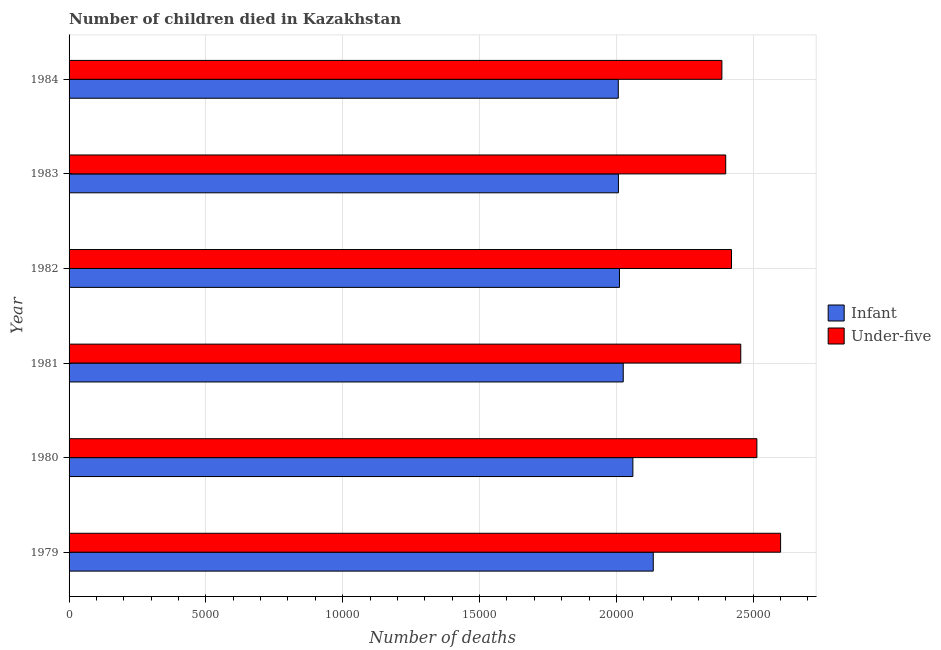How many different coloured bars are there?
Keep it short and to the point. 2. What is the label of the 3rd group of bars from the top?
Keep it short and to the point. 1982. What is the number of infant deaths in 1979?
Keep it short and to the point. 2.13e+04. Across all years, what is the maximum number of under-five deaths?
Offer a terse response. 2.60e+04. Across all years, what is the minimum number of infant deaths?
Keep it short and to the point. 2.01e+04. In which year was the number of infant deaths maximum?
Ensure brevity in your answer.  1979. In which year was the number of under-five deaths minimum?
Give a very brief answer. 1984. What is the total number of infant deaths in the graph?
Offer a terse response. 1.22e+05. What is the difference between the number of infant deaths in 1981 and that in 1984?
Ensure brevity in your answer.  181. What is the difference between the number of under-five deaths in 1981 and the number of infant deaths in 1980?
Make the answer very short. 3943. What is the average number of under-five deaths per year?
Ensure brevity in your answer.  2.46e+04. In the year 1980, what is the difference between the number of under-five deaths and number of infant deaths?
Provide a succinct answer. 4532. What is the ratio of the number of under-five deaths in 1980 to that in 1982?
Provide a succinct answer. 1.04. What is the difference between the highest and the second highest number of infant deaths?
Your response must be concise. 745. What is the difference between the highest and the lowest number of infant deaths?
Provide a succinct answer. 1278. What does the 1st bar from the top in 1981 represents?
Keep it short and to the point. Under-five. What does the 1st bar from the bottom in 1981 represents?
Keep it short and to the point. Infant. Are all the bars in the graph horizontal?
Make the answer very short. Yes. Where does the legend appear in the graph?
Keep it short and to the point. Center right. How many legend labels are there?
Your answer should be very brief. 2. What is the title of the graph?
Offer a terse response. Number of children died in Kazakhstan. What is the label or title of the X-axis?
Offer a very short reply. Number of deaths. What is the Number of deaths of Infant in 1979?
Offer a terse response. 2.13e+04. What is the Number of deaths of Under-five in 1979?
Offer a very short reply. 2.60e+04. What is the Number of deaths in Infant in 1980?
Ensure brevity in your answer.  2.06e+04. What is the Number of deaths of Under-five in 1980?
Your answer should be compact. 2.51e+04. What is the Number of deaths of Infant in 1981?
Give a very brief answer. 2.03e+04. What is the Number of deaths in Under-five in 1981?
Keep it short and to the point. 2.45e+04. What is the Number of deaths in Infant in 1982?
Your response must be concise. 2.01e+04. What is the Number of deaths in Under-five in 1982?
Ensure brevity in your answer.  2.42e+04. What is the Number of deaths of Infant in 1983?
Provide a succinct answer. 2.01e+04. What is the Number of deaths of Under-five in 1983?
Make the answer very short. 2.40e+04. What is the Number of deaths in Infant in 1984?
Your answer should be compact. 2.01e+04. What is the Number of deaths in Under-five in 1984?
Give a very brief answer. 2.39e+04. Across all years, what is the maximum Number of deaths in Infant?
Give a very brief answer. 2.13e+04. Across all years, what is the maximum Number of deaths of Under-five?
Offer a terse response. 2.60e+04. Across all years, what is the minimum Number of deaths of Infant?
Your response must be concise. 2.01e+04. Across all years, what is the minimum Number of deaths in Under-five?
Give a very brief answer. 2.39e+04. What is the total Number of deaths of Infant in the graph?
Offer a very short reply. 1.22e+05. What is the total Number of deaths of Under-five in the graph?
Give a very brief answer. 1.48e+05. What is the difference between the Number of deaths in Infant in 1979 and that in 1980?
Offer a terse response. 745. What is the difference between the Number of deaths of Under-five in 1979 and that in 1980?
Ensure brevity in your answer.  866. What is the difference between the Number of deaths in Infant in 1979 and that in 1981?
Offer a terse response. 1097. What is the difference between the Number of deaths in Under-five in 1979 and that in 1981?
Ensure brevity in your answer.  1455. What is the difference between the Number of deaths of Infant in 1979 and that in 1982?
Provide a succinct answer. 1235. What is the difference between the Number of deaths in Under-five in 1979 and that in 1982?
Your answer should be very brief. 1793. What is the difference between the Number of deaths of Infant in 1979 and that in 1983?
Your response must be concise. 1273. What is the difference between the Number of deaths in Under-five in 1979 and that in 1983?
Provide a succinct answer. 2005. What is the difference between the Number of deaths in Infant in 1979 and that in 1984?
Offer a terse response. 1278. What is the difference between the Number of deaths in Under-five in 1979 and that in 1984?
Keep it short and to the point. 2145. What is the difference between the Number of deaths of Infant in 1980 and that in 1981?
Offer a terse response. 352. What is the difference between the Number of deaths in Under-five in 1980 and that in 1981?
Your answer should be compact. 589. What is the difference between the Number of deaths of Infant in 1980 and that in 1982?
Your answer should be compact. 490. What is the difference between the Number of deaths in Under-five in 1980 and that in 1982?
Offer a terse response. 927. What is the difference between the Number of deaths in Infant in 1980 and that in 1983?
Ensure brevity in your answer.  528. What is the difference between the Number of deaths of Under-five in 1980 and that in 1983?
Your answer should be compact. 1139. What is the difference between the Number of deaths of Infant in 1980 and that in 1984?
Provide a short and direct response. 533. What is the difference between the Number of deaths of Under-five in 1980 and that in 1984?
Ensure brevity in your answer.  1279. What is the difference between the Number of deaths in Infant in 1981 and that in 1982?
Give a very brief answer. 138. What is the difference between the Number of deaths in Under-five in 1981 and that in 1982?
Your answer should be very brief. 338. What is the difference between the Number of deaths in Infant in 1981 and that in 1983?
Your answer should be compact. 176. What is the difference between the Number of deaths of Under-five in 1981 and that in 1983?
Provide a succinct answer. 550. What is the difference between the Number of deaths of Infant in 1981 and that in 1984?
Give a very brief answer. 181. What is the difference between the Number of deaths in Under-five in 1981 and that in 1984?
Provide a succinct answer. 690. What is the difference between the Number of deaths of Under-five in 1982 and that in 1983?
Provide a short and direct response. 212. What is the difference between the Number of deaths of Under-five in 1982 and that in 1984?
Offer a very short reply. 352. What is the difference between the Number of deaths in Under-five in 1983 and that in 1984?
Ensure brevity in your answer.  140. What is the difference between the Number of deaths in Infant in 1979 and the Number of deaths in Under-five in 1980?
Provide a short and direct response. -3787. What is the difference between the Number of deaths of Infant in 1979 and the Number of deaths of Under-five in 1981?
Ensure brevity in your answer.  -3198. What is the difference between the Number of deaths in Infant in 1979 and the Number of deaths in Under-five in 1982?
Offer a terse response. -2860. What is the difference between the Number of deaths in Infant in 1979 and the Number of deaths in Under-five in 1983?
Your answer should be very brief. -2648. What is the difference between the Number of deaths of Infant in 1979 and the Number of deaths of Under-five in 1984?
Give a very brief answer. -2508. What is the difference between the Number of deaths in Infant in 1980 and the Number of deaths in Under-five in 1981?
Offer a terse response. -3943. What is the difference between the Number of deaths of Infant in 1980 and the Number of deaths of Under-five in 1982?
Your response must be concise. -3605. What is the difference between the Number of deaths in Infant in 1980 and the Number of deaths in Under-five in 1983?
Give a very brief answer. -3393. What is the difference between the Number of deaths in Infant in 1980 and the Number of deaths in Under-five in 1984?
Your answer should be compact. -3253. What is the difference between the Number of deaths in Infant in 1981 and the Number of deaths in Under-five in 1982?
Provide a short and direct response. -3957. What is the difference between the Number of deaths of Infant in 1981 and the Number of deaths of Under-five in 1983?
Your answer should be compact. -3745. What is the difference between the Number of deaths in Infant in 1981 and the Number of deaths in Under-five in 1984?
Provide a short and direct response. -3605. What is the difference between the Number of deaths in Infant in 1982 and the Number of deaths in Under-five in 1983?
Your response must be concise. -3883. What is the difference between the Number of deaths in Infant in 1982 and the Number of deaths in Under-five in 1984?
Make the answer very short. -3743. What is the difference between the Number of deaths of Infant in 1983 and the Number of deaths of Under-five in 1984?
Keep it short and to the point. -3781. What is the average Number of deaths in Infant per year?
Offer a terse response. 2.04e+04. What is the average Number of deaths of Under-five per year?
Ensure brevity in your answer.  2.46e+04. In the year 1979, what is the difference between the Number of deaths of Infant and Number of deaths of Under-five?
Provide a short and direct response. -4653. In the year 1980, what is the difference between the Number of deaths of Infant and Number of deaths of Under-five?
Your response must be concise. -4532. In the year 1981, what is the difference between the Number of deaths in Infant and Number of deaths in Under-five?
Provide a succinct answer. -4295. In the year 1982, what is the difference between the Number of deaths in Infant and Number of deaths in Under-five?
Ensure brevity in your answer.  -4095. In the year 1983, what is the difference between the Number of deaths of Infant and Number of deaths of Under-five?
Your response must be concise. -3921. In the year 1984, what is the difference between the Number of deaths in Infant and Number of deaths in Under-five?
Your response must be concise. -3786. What is the ratio of the Number of deaths in Infant in 1979 to that in 1980?
Your response must be concise. 1.04. What is the ratio of the Number of deaths in Under-five in 1979 to that in 1980?
Make the answer very short. 1.03. What is the ratio of the Number of deaths in Infant in 1979 to that in 1981?
Make the answer very short. 1.05. What is the ratio of the Number of deaths of Under-five in 1979 to that in 1981?
Offer a very short reply. 1.06. What is the ratio of the Number of deaths in Infant in 1979 to that in 1982?
Ensure brevity in your answer.  1.06. What is the ratio of the Number of deaths in Under-five in 1979 to that in 1982?
Keep it short and to the point. 1.07. What is the ratio of the Number of deaths of Infant in 1979 to that in 1983?
Keep it short and to the point. 1.06. What is the ratio of the Number of deaths of Under-five in 1979 to that in 1983?
Ensure brevity in your answer.  1.08. What is the ratio of the Number of deaths in Infant in 1979 to that in 1984?
Make the answer very short. 1.06. What is the ratio of the Number of deaths in Under-five in 1979 to that in 1984?
Ensure brevity in your answer.  1.09. What is the ratio of the Number of deaths in Infant in 1980 to that in 1981?
Offer a very short reply. 1.02. What is the ratio of the Number of deaths in Infant in 1980 to that in 1982?
Provide a short and direct response. 1.02. What is the ratio of the Number of deaths in Under-five in 1980 to that in 1982?
Keep it short and to the point. 1.04. What is the ratio of the Number of deaths in Infant in 1980 to that in 1983?
Your response must be concise. 1.03. What is the ratio of the Number of deaths in Under-five in 1980 to that in 1983?
Make the answer very short. 1.05. What is the ratio of the Number of deaths of Infant in 1980 to that in 1984?
Offer a terse response. 1.03. What is the ratio of the Number of deaths of Under-five in 1980 to that in 1984?
Offer a terse response. 1.05. What is the ratio of the Number of deaths in Infant in 1981 to that in 1983?
Provide a succinct answer. 1.01. What is the ratio of the Number of deaths of Under-five in 1981 to that in 1983?
Make the answer very short. 1.02. What is the ratio of the Number of deaths in Under-five in 1981 to that in 1984?
Your answer should be compact. 1.03. What is the ratio of the Number of deaths in Infant in 1982 to that in 1983?
Your answer should be very brief. 1. What is the ratio of the Number of deaths in Under-five in 1982 to that in 1983?
Your answer should be compact. 1.01. What is the ratio of the Number of deaths of Under-five in 1982 to that in 1984?
Give a very brief answer. 1.01. What is the ratio of the Number of deaths of Under-five in 1983 to that in 1984?
Ensure brevity in your answer.  1.01. What is the difference between the highest and the second highest Number of deaths in Infant?
Ensure brevity in your answer.  745. What is the difference between the highest and the second highest Number of deaths in Under-five?
Your response must be concise. 866. What is the difference between the highest and the lowest Number of deaths in Infant?
Your answer should be very brief. 1278. What is the difference between the highest and the lowest Number of deaths of Under-five?
Ensure brevity in your answer.  2145. 